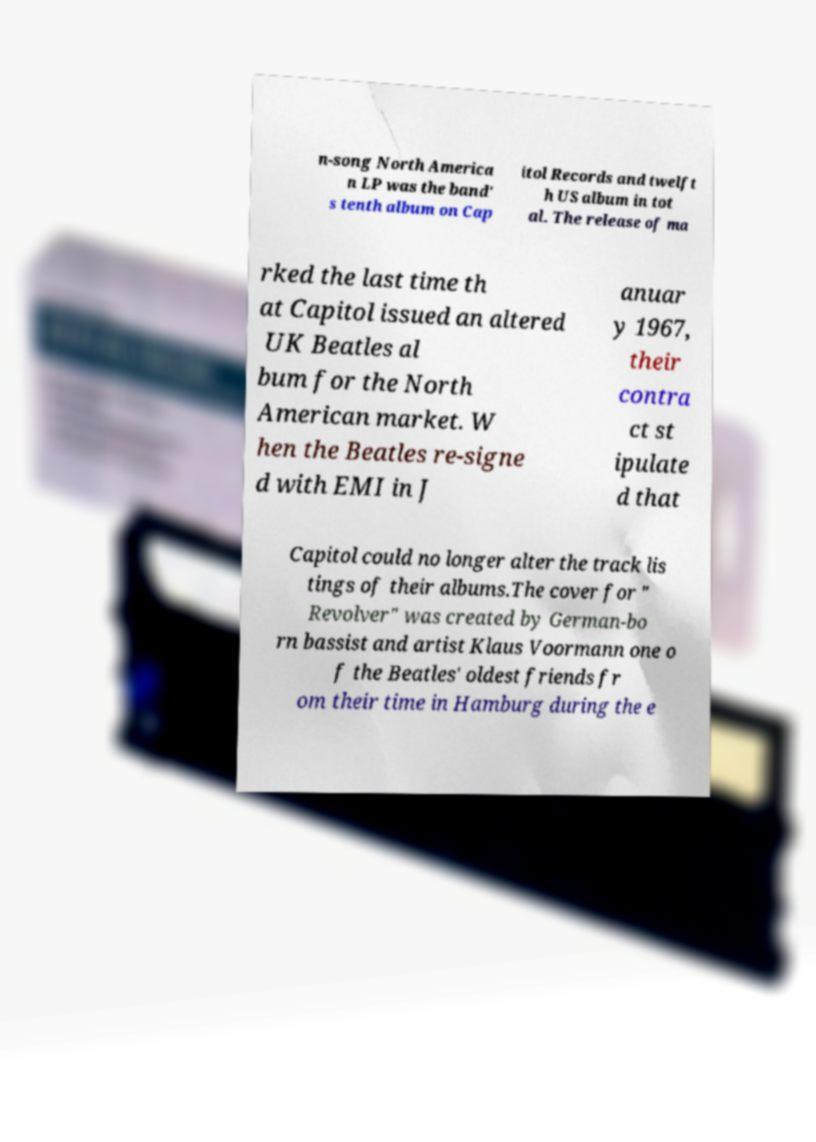Could you extract and type out the text from this image? n-song North America n LP was the band' s tenth album on Cap itol Records and twelft h US album in tot al. The release of ma rked the last time th at Capitol issued an altered UK Beatles al bum for the North American market. W hen the Beatles re-signe d with EMI in J anuar y 1967, their contra ct st ipulate d that Capitol could no longer alter the track lis tings of their albums.The cover for " Revolver" was created by German-bo rn bassist and artist Klaus Voormann one o f the Beatles' oldest friends fr om their time in Hamburg during the e 